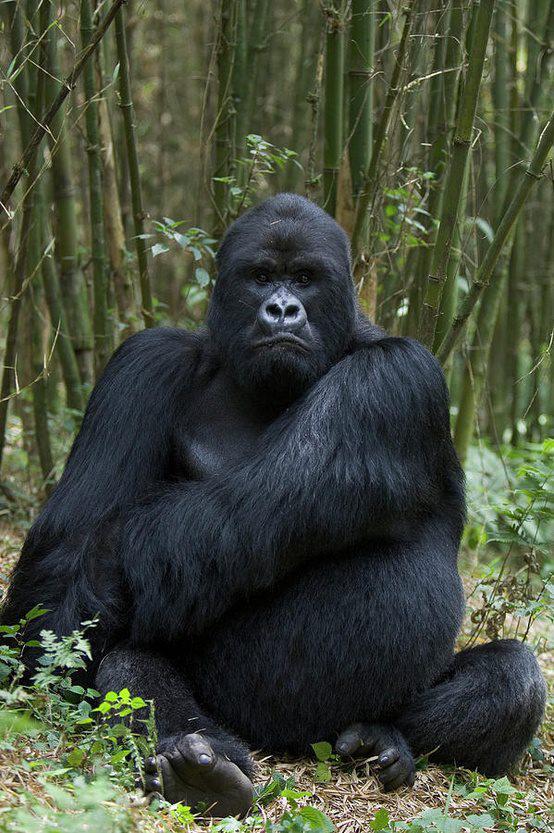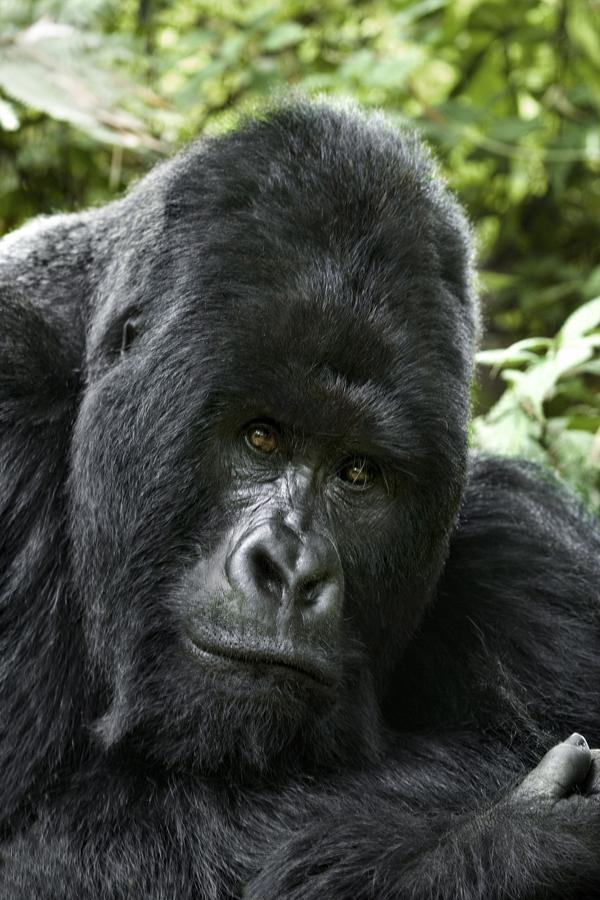The first image is the image on the left, the second image is the image on the right. Examine the images to the left and right. Is the description "There are more primates in the image on the right." accurate? Answer yes or no. No. The first image is the image on the left, the second image is the image on the right. Considering the images on both sides, is "The left image shows a back-turned adult gorilla with a hump-shaped head standing upright and face-to-face with one other gorilla." valid? Answer yes or no. No. 